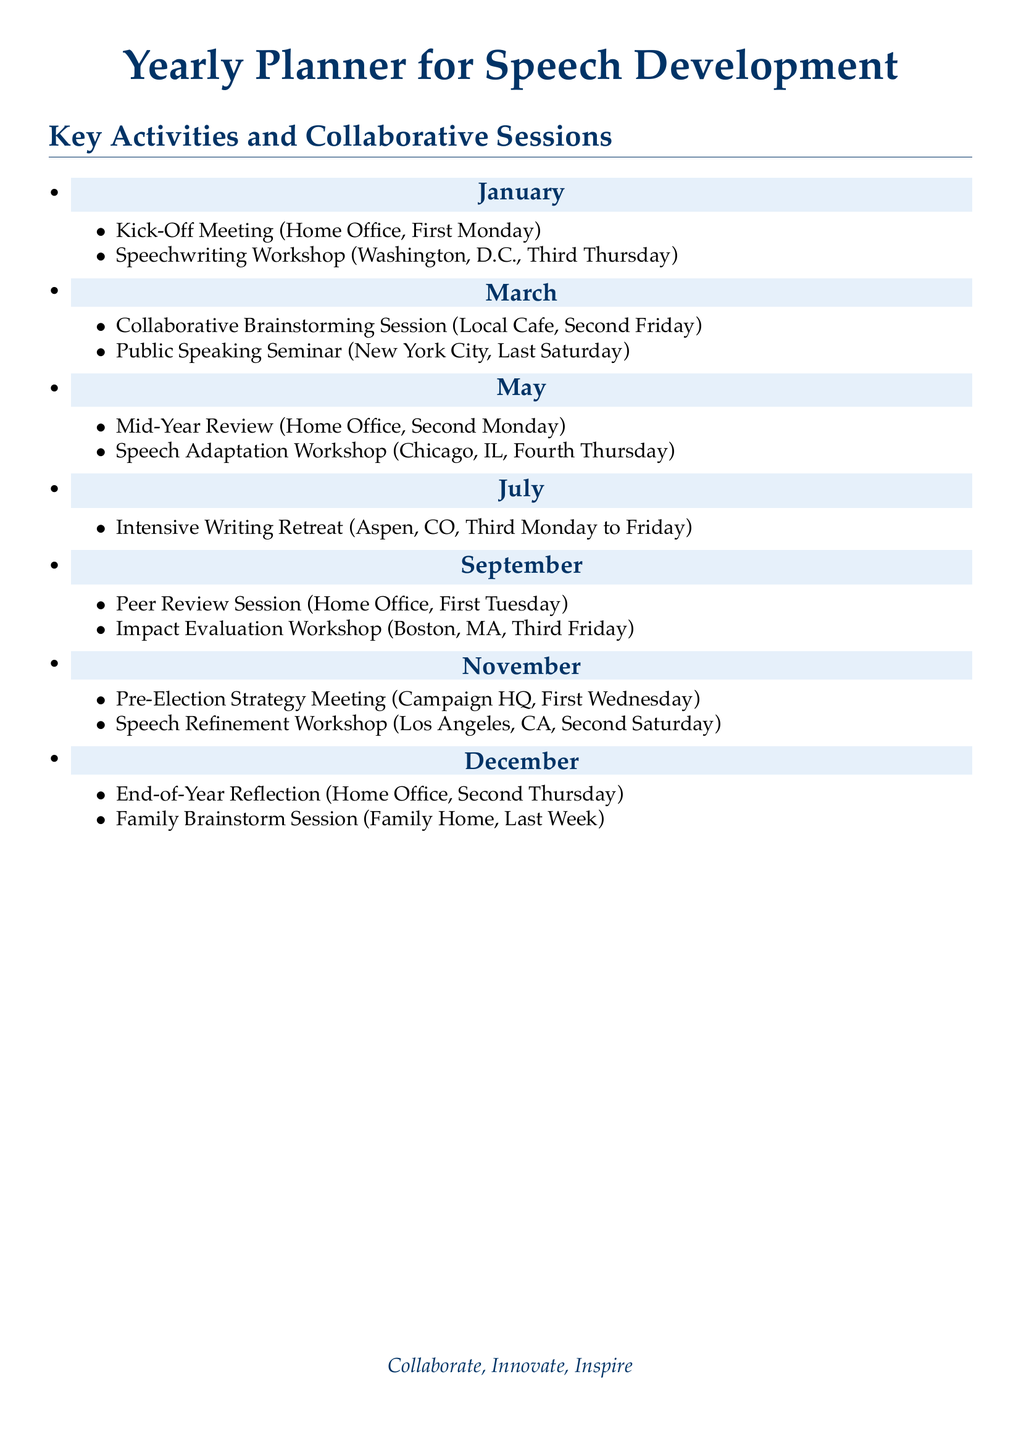What is the first activity of the year? The first activity of the year is the Kick-Off Meeting scheduled for the first Monday of January.
Answer: Kick-Off Meeting Which city hosts the Public Speaking Seminar? The Public Speaking Seminar takes place in New York City on the last Saturday of March.
Answer: New York City How many sessions are planned in November? In November, there are two scheduled sessions: the Pre-Election Strategy Meeting and the Speech Refinement Workshop.
Answer: Two What is the date of the Intensive Writing Retreat? The Intensive Writing Retreat occurs from the third Monday to Friday of July.
Answer: Third Monday to Friday What month is allocated for the Mid-Year Review? The Mid-Year Review is scheduled for May on the second Monday.
Answer: May 